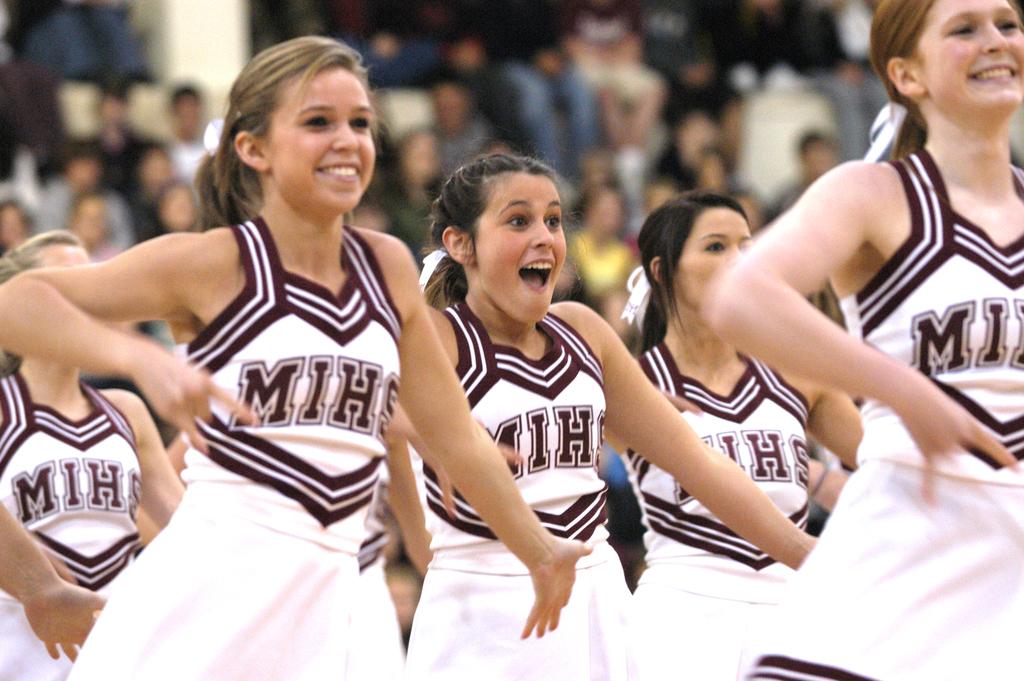What school do the cheerleaders represent?
Your answer should be very brief. Mihs. 